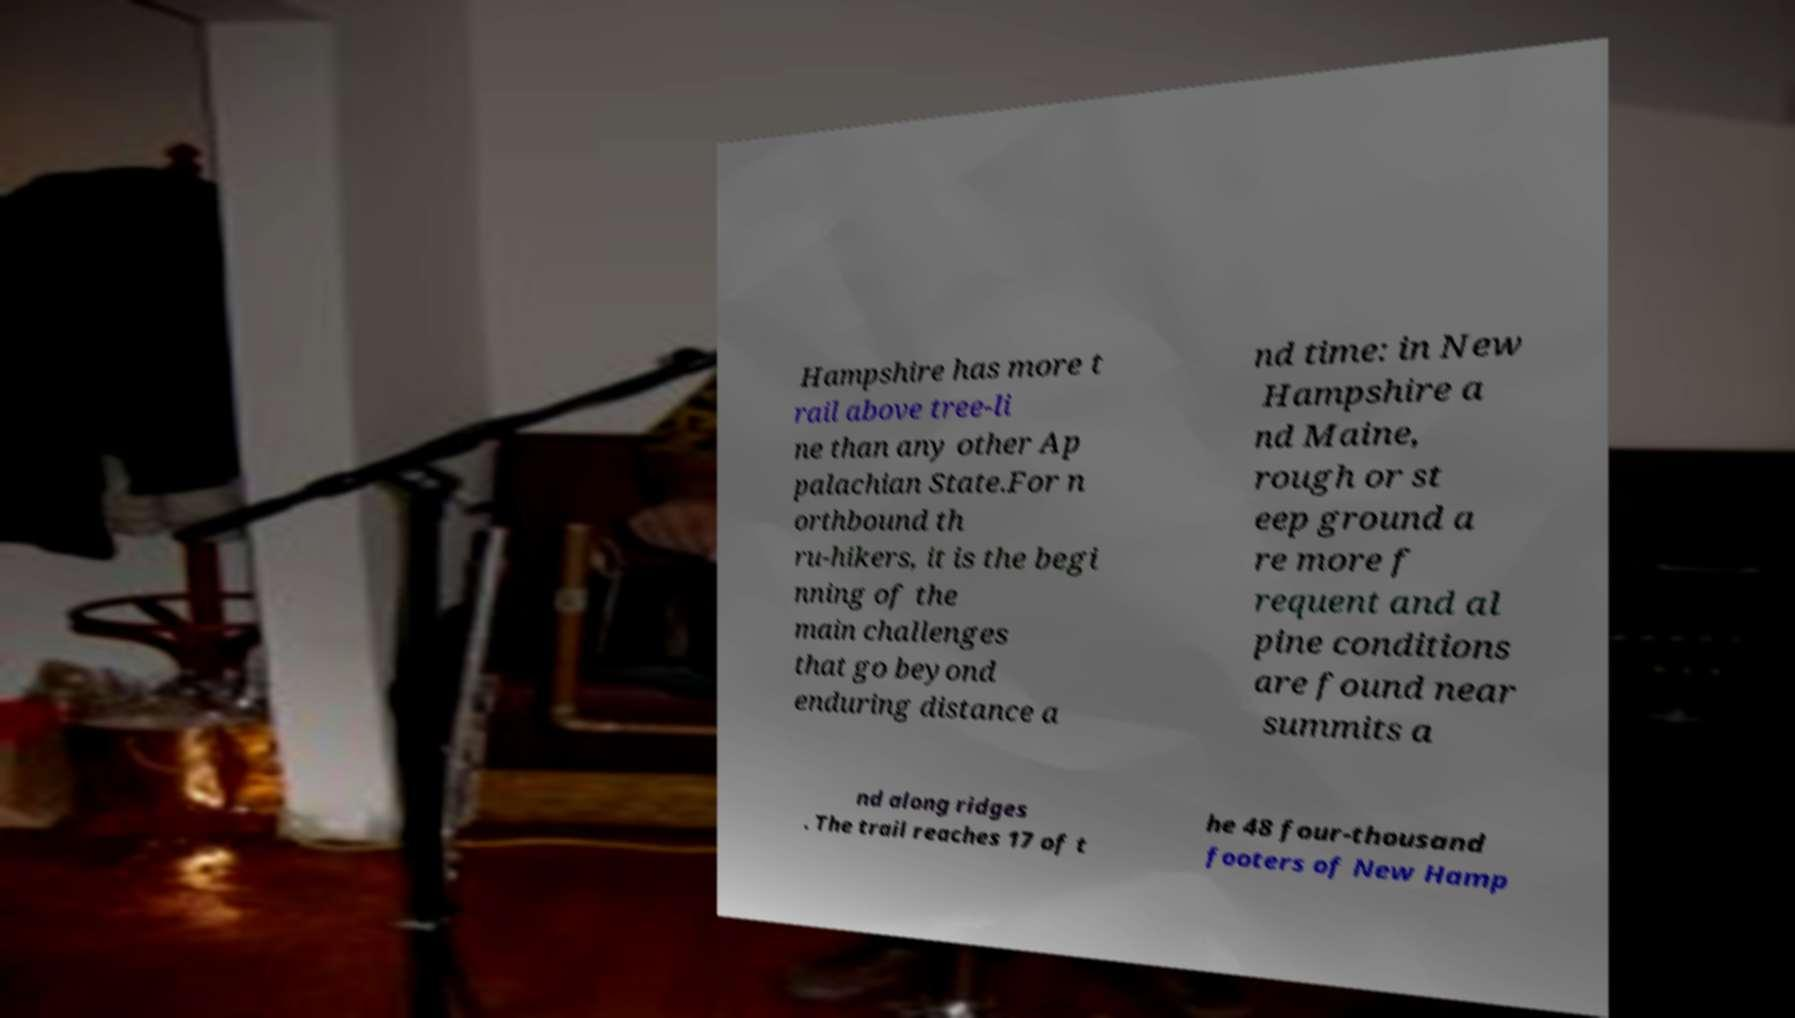Can you accurately transcribe the text from the provided image for me? Hampshire has more t rail above tree-li ne than any other Ap palachian State.For n orthbound th ru-hikers, it is the begi nning of the main challenges that go beyond enduring distance a nd time: in New Hampshire a nd Maine, rough or st eep ground a re more f requent and al pine conditions are found near summits a nd along ridges . The trail reaches 17 of t he 48 four-thousand footers of New Hamp 